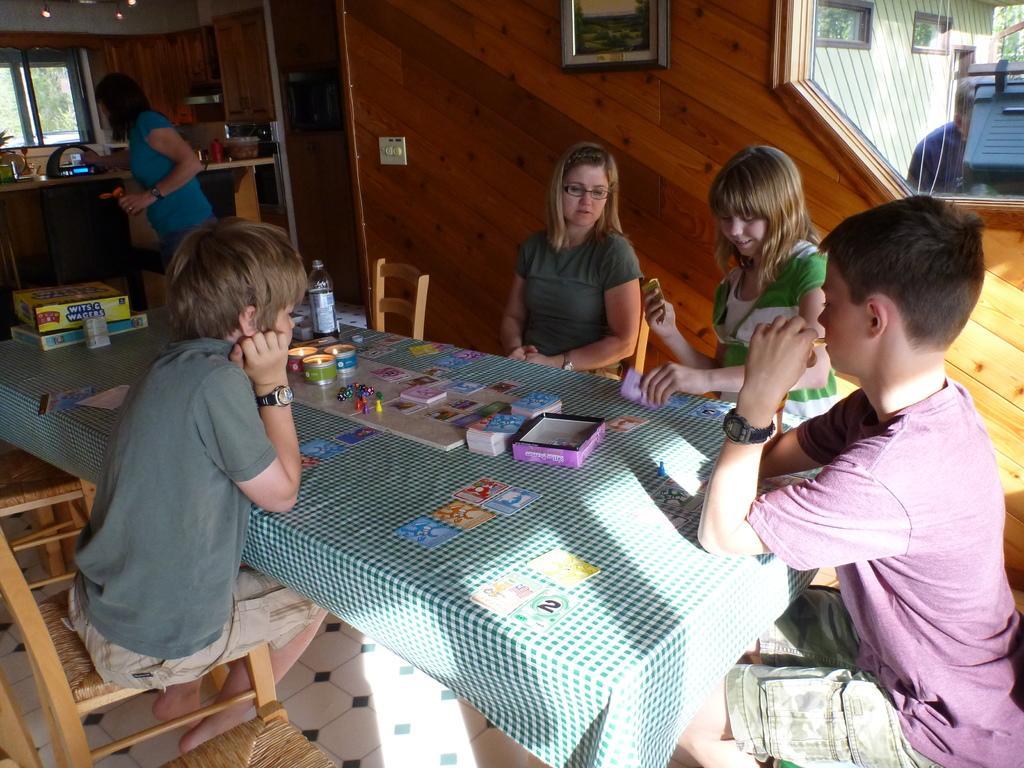Can you describe this image briefly? In the picture there are four kids sitting around the table and a woman, the kids are playing a game,the is a big table in front of them on which the game is placed, there is also a bottle on the table. In front of the woman there is a toaster she is holding something in her left hand and there is also a window in front of her, in the background there is a wooden wall, a glass window out of the window there is a person doing some other work and also a building. 